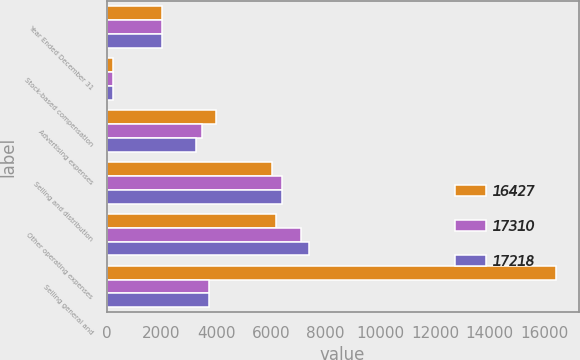Convert chart to OTSL. <chart><loc_0><loc_0><loc_500><loc_500><stacked_bar_chart><ecel><fcel>Year Ended December 31<fcel>Stock-based compensation<fcel>Advertising expenses<fcel>Selling and distribution<fcel>Other operating expenses<fcel>Selling general and<nl><fcel>16427<fcel>2015<fcel>236<fcel>3976<fcel>6025<fcel>6190<fcel>16427<nl><fcel>17310<fcel>2014<fcel>209<fcel>3499<fcel>6412<fcel>7098<fcel>3737.5<nl><fcel>17218<fcel>2013<fcel>227<fcel>3266<fcel>6419<fcel>7398<fcel>3737.5<nl></chart> 